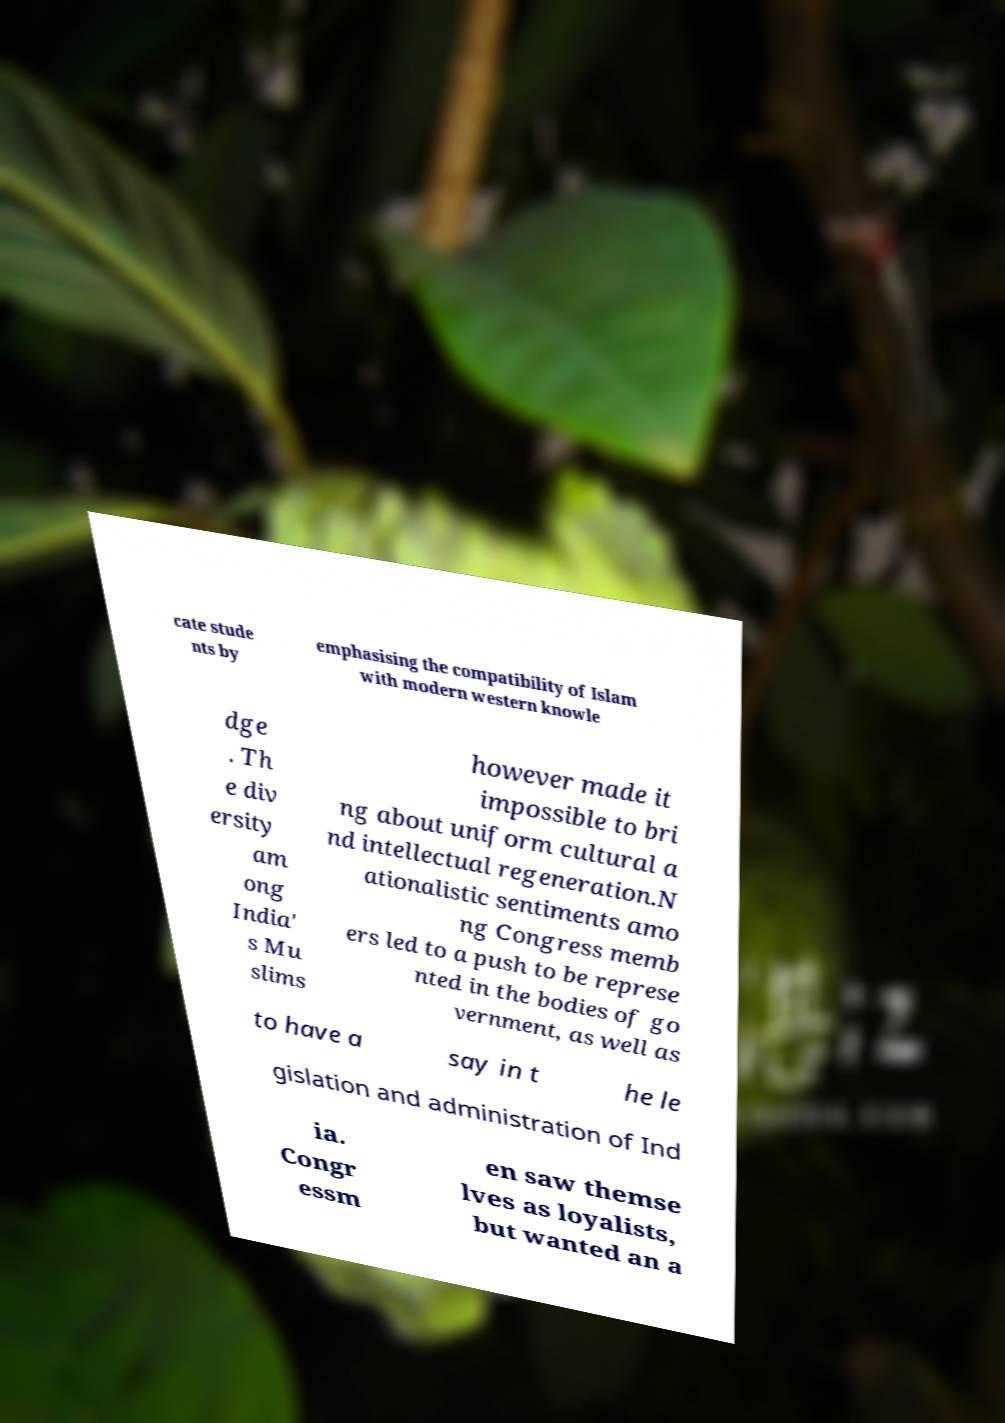What messages or text are displayed in this image? I need them in a readable, typed format. cate stude nts by emphasising the compatibility of Islam with modern western knowle dge . Th e div ersity am ong India' s Mu slims however made it impossible to bri ng about uniform cultural a nd intellectual regeneration.N ationalistic sentiments amo ng Congress memb ers led to a push to be represe nted in the bodies of go vernment, as well as to have a say in t he le gislation and administration of Ind ia. Congr essm en saw themse lves as loyalists, but wanted an a 